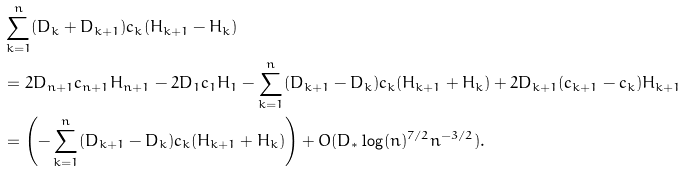<formula> <loc_0><loc_0><loc_500><loc_500>& \sum _ { k = 1 } ^ { n } ( D _ { k } + D _ { k + 1 } ) c _ { k } ( H _ { k + 1 } - H _ { k } ) \\ & = 2 D _ { n + 1 } c _ { n + 1 } H _ { n + 1 } - 2 D _ { 1 } c _ { 1 } H _ { 1 } - \sum _ { k = 1 } ^ { n } ( D _ { k + 1 } - D _ { k } ) c _ { k } ( H _ { k + 1 } + H _ { k } ) + 2 D _ { k + 1 } ( c _ { k + 1 } - c _ { k } ) H _ { k + 1 } \\ & = \left ( - \sum _ { k = 1 } ^ { n } ( D _ { k + 1 } - D _ { k } ) c _ { k } ( H _ { k + 1 } + H _ { k } ) \right ) + O ( D _ { \ast } \log ( n ) ^ { 7 / 2 } n ^ { - 3 / 2 } ) .</formula> 